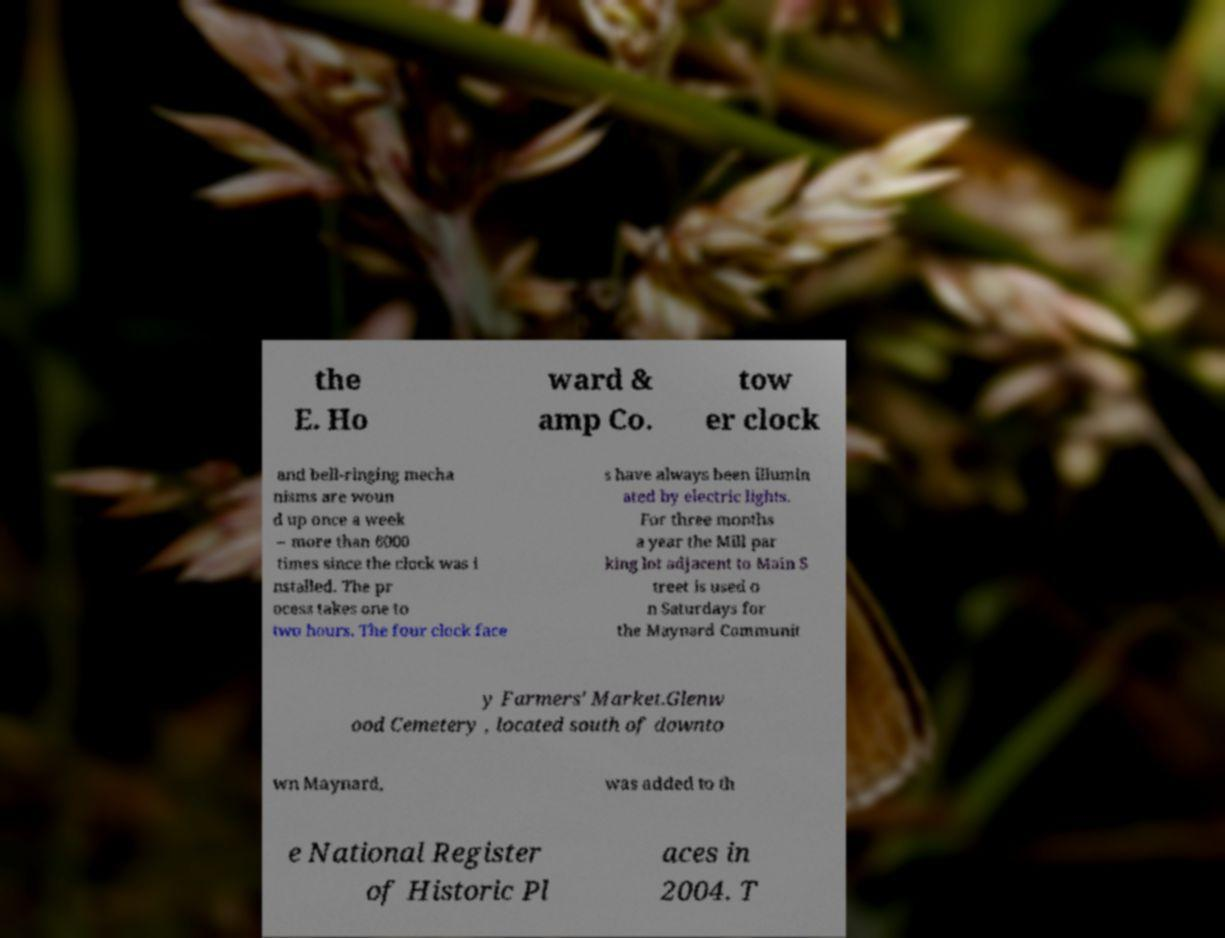What messages or text are displayed in this image? I need them in a readable, typed format. the E. Ho ward & amp Co. tow er clock and bell-ringing mecha nisms are woun d up once a week – more than 6000 times since the clock was i nstalled. The pr ocess takes one to two hours. The four clock face s have always been illumin ated by electric lights. For three months a year the Mill par king lot adjacent to Main S treet is used o n Saturdays for the Maynard Communit y Farmers' Market.Glenw ood Cemetery , located south of downto wn Maynard, was added to th e National Register of Historic Pl aces in 2004. T 